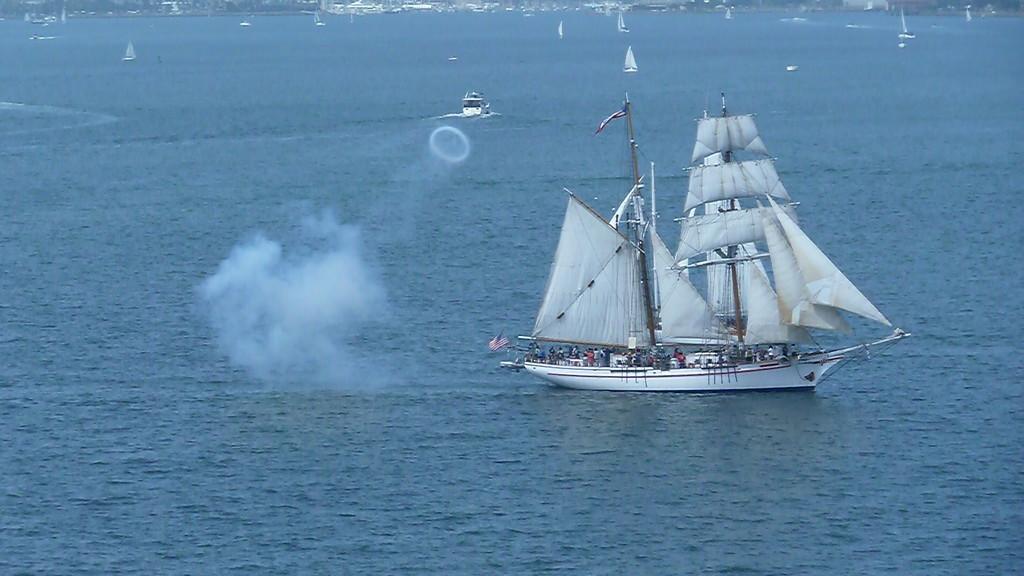Could you give a brief overview of what you see in this image? In this image we can see a ship, people and other objects. At the bottom of the image there is the water. In the background of the image there are ships, water and other objects. 